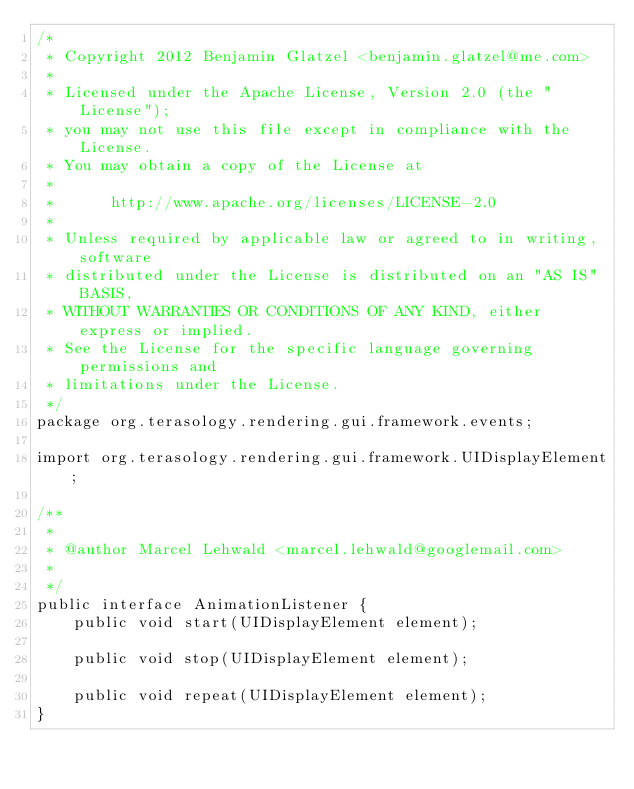Convert code to text. <code><loc_0><loc_0><loc_500><loc_500><_Java_>/*
 * Copyright 2012 Benjamin Glatzel <benjamin.glatzel@me.com>
 *
 * Licensed under the Apache License, Version 2.0 (the "License");
 * you may not use this file except in compliance with the License.
 * You may obtain a copy of the License at
 *
 *      http://www.apache.org/licenses/LICENSE-2.0
 *
 * Unless required by applicable law or agreed to in writing, software
 * distributed under the License is distributed on an "AS IS" BASIS,
 * WITHOUT WARRANTIES OR CONDITIONS OF ANY KIND, either express or implied.
 * See the License for the specific language governing permissions and
 * limitations under the License.
 */
package org.terasology.rendering.gui.framework.events;

import org.terasology.rendering.gui.framework.UIDisplayElement;

/**
 * 
 * @author Marcel Lehwald <marcel.lehwald@googlemail.com>
 *
 */
public interface AnimationListener {
    public void start(UIDisplayElement element);
    
    public void stop(UIDisplayElement element);
    
    public void repeat(UIDisplayElement element);
}
</code> 